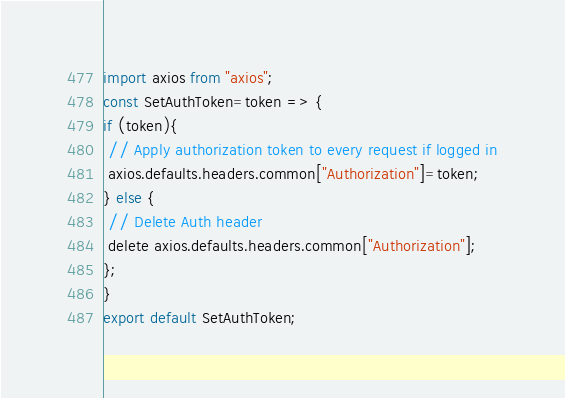Convert code to text. <code><loc_0><loc_0><loc_500><loc_500><_JavaScript_>import axios from "axios";
const SetAuthToken=token => {
if (token){
 // Apply authorization token to every request if logged in
 axios.defaults.headers.common["Authorization"]=token;
} else {
 // Delete Auth header
 delete axios.defaults.headers.common["Authorization"];
};
}
export default SetAuthToken;</code> 